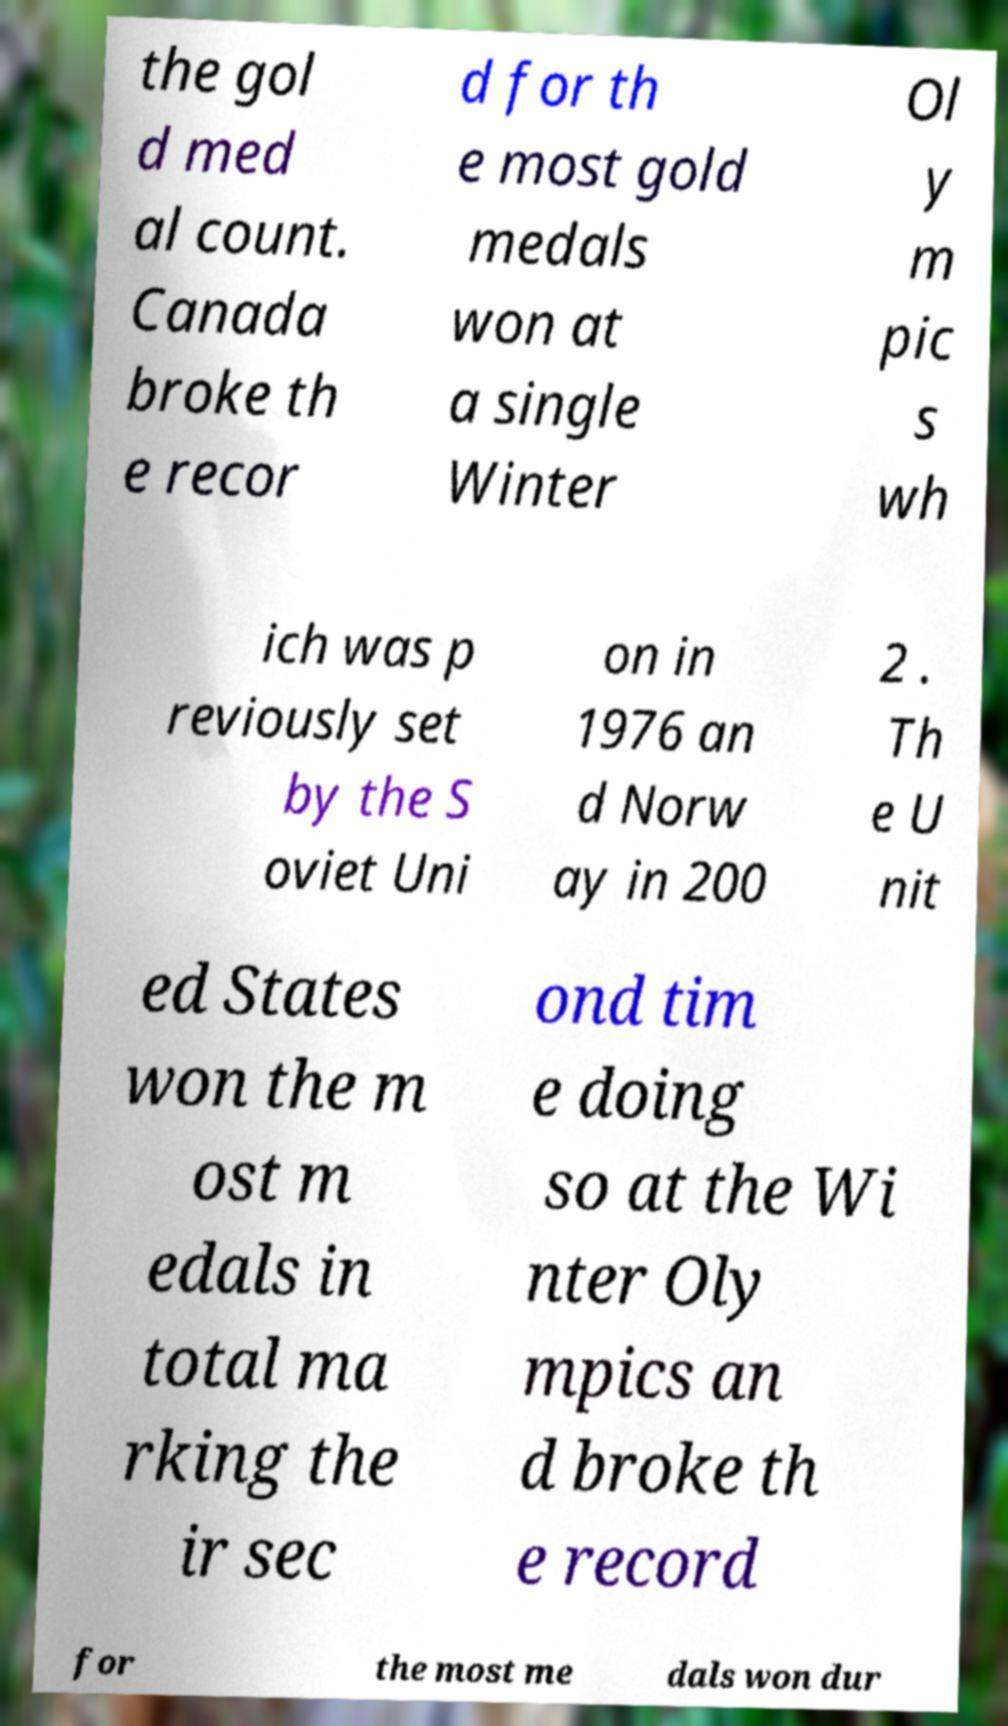Please identify and transcribe the text found in this image. the gol d med al count. Canada broke th e recor d for th e most gold medals won at a single Winter Ol y m pic s wh ich was p reviously set by the S oviet Uni on in 1976 an d Norw ay in 200 2 . Th e U nit ed States won the m ost m edals in total ma rking the ir sec ond tim e doing so at the Wi nter Oly mpics an d broke th e record for the most me dals won dur 